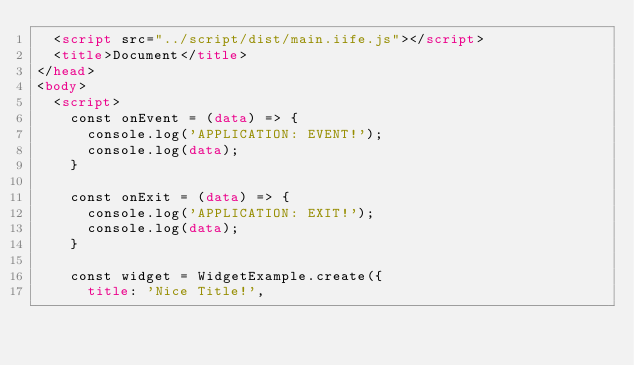Convert code to text. <code><loc_0><loc_0><loc_500><loc_500><_HTML_>  <script src="../script/dist/main.iife.js"></script>
  <title>Document</title>
</head>
<body>
  <script>
    const onEvent = (data) => {
      console.log('APPLICATION: EVENT!');
      console.log(data);
    }

    const onExit = (data) => {
      console.log('APPLICATION: EXIT!');
      console.log(data);
    }

    const widget = WidgetExample.create({
      title: 'Nice Title!',</code> 